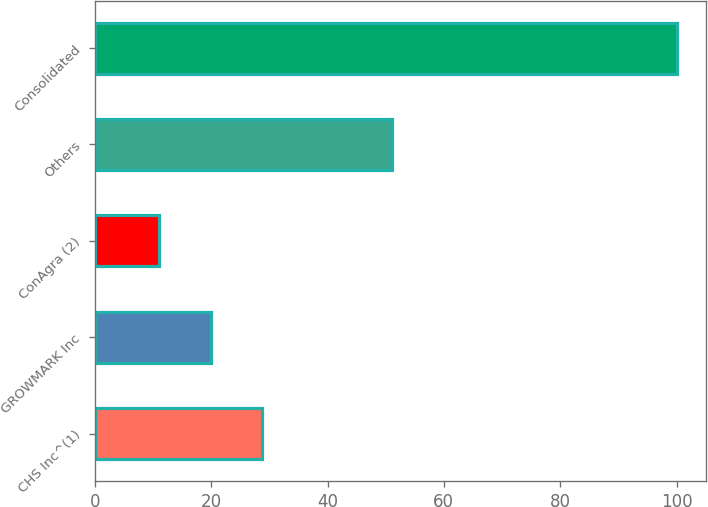Convert chart to OTSL. <chart><loc_0><loc_0><loc_500><loc_500><bar_chart><fcel>CHS Inc^(1)<fcel>GROWMARK Inc<fcel>ConAgra (2)<fcel>Others<fcel>Consolidated<nl><fcel>28.8<fcel>19.9<fcel>11<fcel>51<fcel>100<nl></chart> 